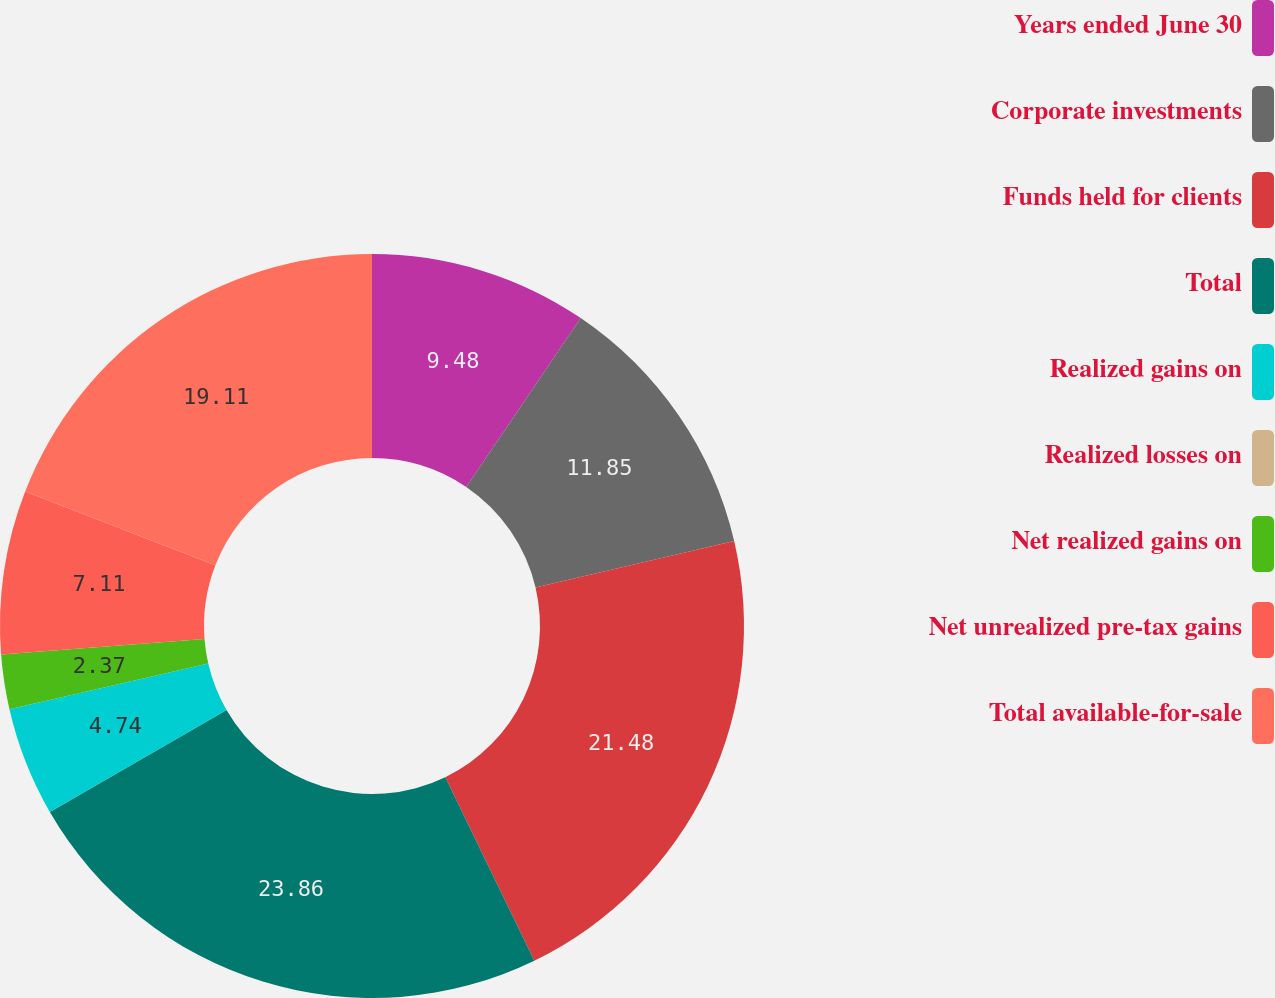<chart> <loc_0><loc_0><loc_500><loc_500><pie_chart><fcel>Years ended June 30<fcel>Corporate investments<fcel>Funds held for clients<fcel>Total<fcel>Realized gains on<fcel>Realized losses on<fcel>Net realized gains on<fcel>Net unrealized pre-tax gains<fcel>Total available-for-sale<nl><fcel>9.48%<fcel>11.85%<fcel>21.48%<fcel>23.85%<fcel>4.74%<fcel>0.0%<fcel>2.37%<fcel>7.11%<fcel>19.11%<nl></chart> 